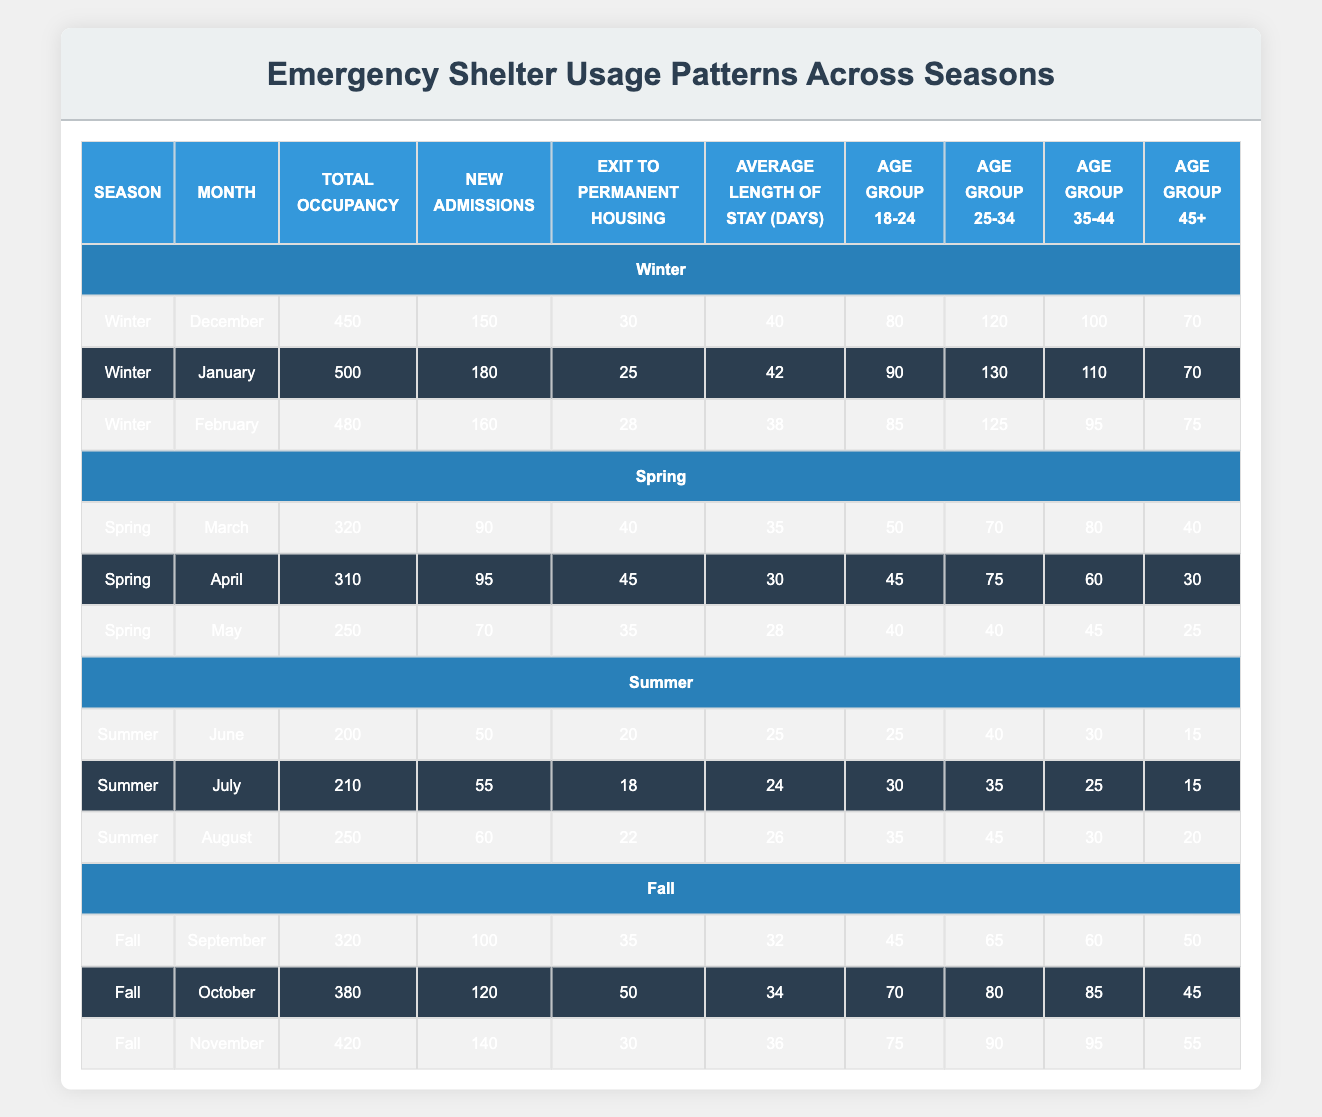What was the total occupancy in January during the winter season? The table indicates that the total occupancy in January (winter) was specifically noted. I can find this information directly in the January row under the winter season. It lists a total occupancy of 500.
Answer: 500 Which month had the highest average length of stay during spring? In the spring section of the table, I can evaluate the average length of stay in days for March, April, and May. March shows 35 days, April shows 30 days, and May shows 28 days. The highest among these values is March with 35 days.
Answer: 35 Did the exit to permanent housing in February exceed the exit in January during winter? The table shows the exit to permanent housing figures: February had 28 exits and January had 25 exits. Since 28 is greater than 25, the statement is true.
Answer: Yes How many new admissions were there across the summer months combined? I need to add the new admissions for June, July, and August together. June had 50 admissions, July had 55, and August had 60. Summing these gives 50 + 55 + 60 = 165.
Answer: 165 In which month of fall was the total occupancy the highest? By looking at the fall section, I can find the total occupancy for September (320), October (380), and November (420). The highest value here is November with 420.
Answer: November What percentage of new admissions in October resulted in exits to permanent housing? In October, there were 120 new admissions and 50 exits to permanent housing. To find the percentage, I calculate (50/120) * 100 ≈ 41.67%. This requires dividing the number of exits by the number of admissions and then multiplying by 100 to convert to a percentage.
Answer: Approximately 41.67% Which age group had the lowest total occupancy in the months of winter? Summing the age groups in December (80 for 18-24, 120 for 25-34, 100 for 35-44, and 70 for 45+) gives totals across all months and then comparing for January (90, 130, 110, 70) and February (85, 125, 95, 75). Across all months, the age group 45+ had the lowest total across winter months. Their occupancy totals are 70 (December), 70 (January), and 75 (February), which results in a total of 215.
Answer: 45+ 